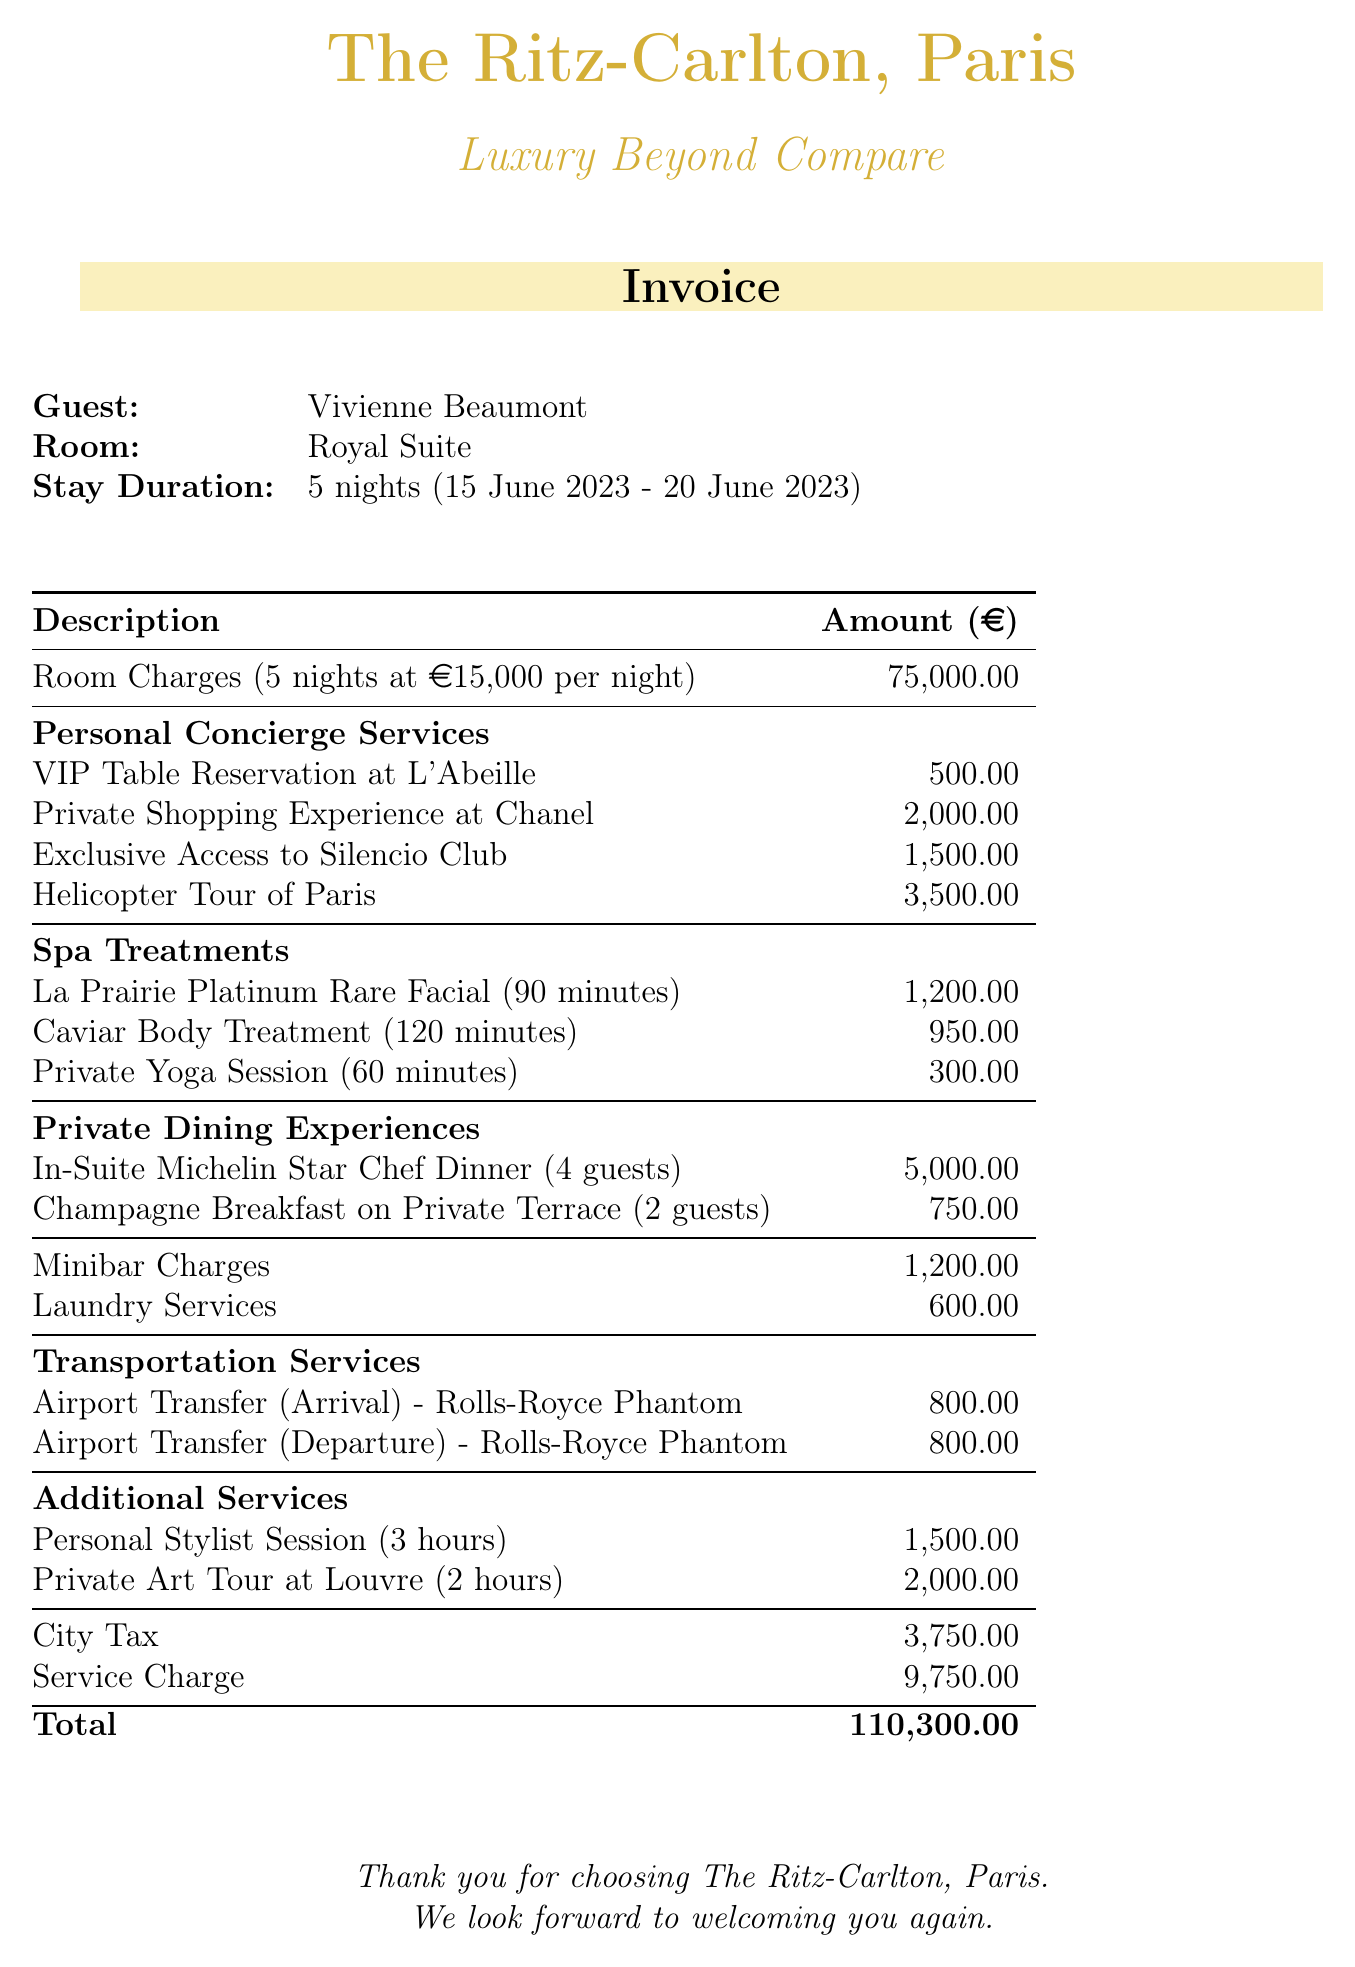What is the name of the hotel? The hotel name can be found at the top of the invoice.
Answer: The Ritz-Carlton, Paris Who is the guest? The guest's name is listed in the document under the guest details section.
Answer: Vivienne Beaumont What is the duration of the stay? The duration of the stay is mentioned in the stay details section of the invoice.
Answer: 5 nights What is the total room charge? The total room charge is calculated based on the nightly rate and stay duration.
Answer: 75000 How much was spent on personal concierge services? The charges for personal concierge services are listed individually, and their total can be calculated.
Answer: 6500 What was the charge for the helicopter tour of Paris? The helicopter tour charge is specified in the personal concierge services section.
Answer: 3500 How many guests were included in the in-suite dinner? The number of guests for the in-suite dinner is noted in the private dining experiences section.
Answer: 4 What tax is included in the total bill? The tax details, including city tax, are provided in the invoice before the total is stated.
Answer: 3750 What is the total bill amount? The total bill is shown at the end of the invoice, summing all charges.
Answer: 110300 